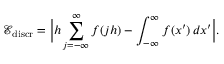<formula> <loc_0><loc_0><loc_500><loc_500>\mathcal { E } _ { d i s c r } = \left | h \sum _ { j = - \infty } ^ { \infty } f ( j h ) - \int _ { - \infty } ^ { \infty } f ( x ^ { \prime } ) \, d x ^ { \prime } \right | .</formula> 